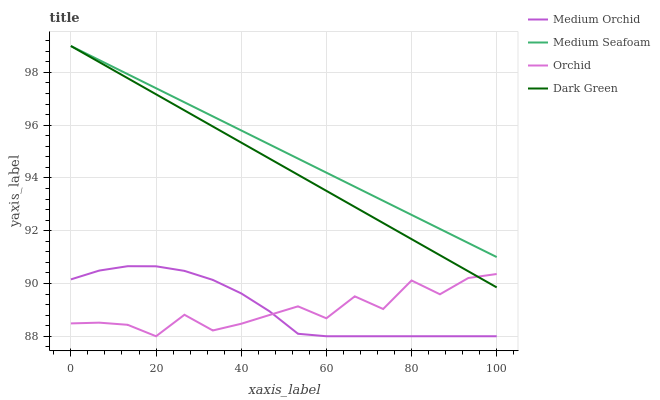Does Orchid have the minimum area under the curve?
Answer yes or no. Yes. Does Medium Seafoam have the maximum area under the curve?
Answer yes or no. Yes. Does Medium Orchid have the minimum area under the curve?
Answer yes or no. No. Does Medium Orchid have the maximum area under the curve?
Answer yes or no. No. Is Dark Green the smoothest?
Answer yes or no. Yes. Is Orchid the roughest?
Answer yes or no. Yes. Is Medium Orchid the smoothest?
Answer yes or no. No. Is Medium Orchid the roughest?
Answer yes or no. No. Does Medium Orchid have the lowest value?
Answer yes or no. Yes. Does Medium Seafoam have the lowest value?
Answer yes or no. No. Does Medium Seafoam have the highest value?
Answer yes or no. Yes. Does Medium Orchid have the highest value?
Answer yes or no. No. Is Orchid less than Medium Seafoam?
Answer yes or no. Yes. Is Medium Seafoam greater than Medium Orchid?
Answer yes or no. Yes. Does Medium Seafoam intersect Dark Green?
Answer yes or no. Yes. Is Medium Seafoam less than Dark Green?
Answer yes or no. No. Is Medium Seafoam greater than Dark Green?
Answer yes or no. No. Does Orchid intersect Medium Seafoam?
Answer yes or no. No. 